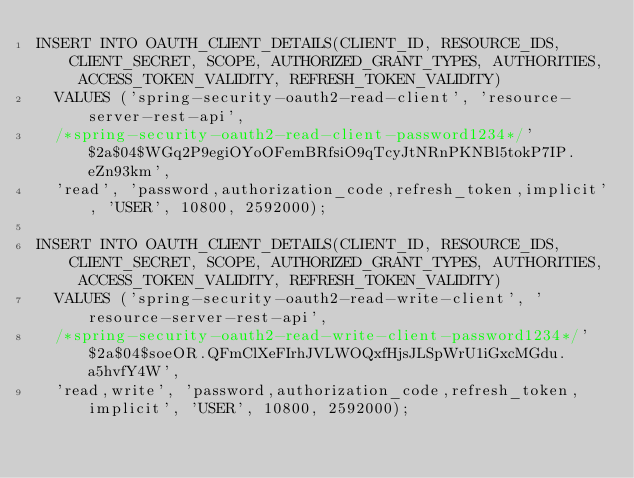<code> <loc_0><loc_0><loc_500><loc_500><_SQL_>INSERT INTO OAUTH_CLIENT_DETAILS(CLIENT_ID, RESOURCE_IDS, CLIENT_SECRET, SCOPE, AUTHORIZED_GRANT_TYPES, AUTHORITIES, ACCESS_TOKEN_VALIDITY, REFRESH_TOKEN_VALIDITY)
	VALUES ('spring-security-oauth2-read-client', 'resource-server-rest-api',
	/*spring-security-oauth2-read-client-password1234*/'$2a$04$WGq2P9egiOYoOFemBRfsiO9qTcyJtNRnPKNBl5tokP7IP.eZn93km',
	'read', 'password,authorization_code,refresh_token,implicit', 'USER', 10800, 2592000);

INSERT INTO OAUTH_CLIENT_DETAILS(CLIENT_ID, RESOURCE_IDS, CLIENT_SECRET, SCOPE, AUTHORIZED_GRANT_TYPES, AUTHORITIES, ACCESS_TOKEN_VALIDITY, REFRESH_TOKEN_VALIDITY)
	VALUES ('spring-security-oauth2-read-write-client', 'resource-server-rest-api',
	/*spring-security-oauth2-read-write-client-password1234*/'$2a$04$soeOR.QFmClXeFIrhJVLWOQxfHjsJLSpWrU1iGxcMGdu.a5hvfY4W',
	'read,write', 'password,authorization_code,refresh_token,implicit', 'USER', 10800, 2592000);
</code> 